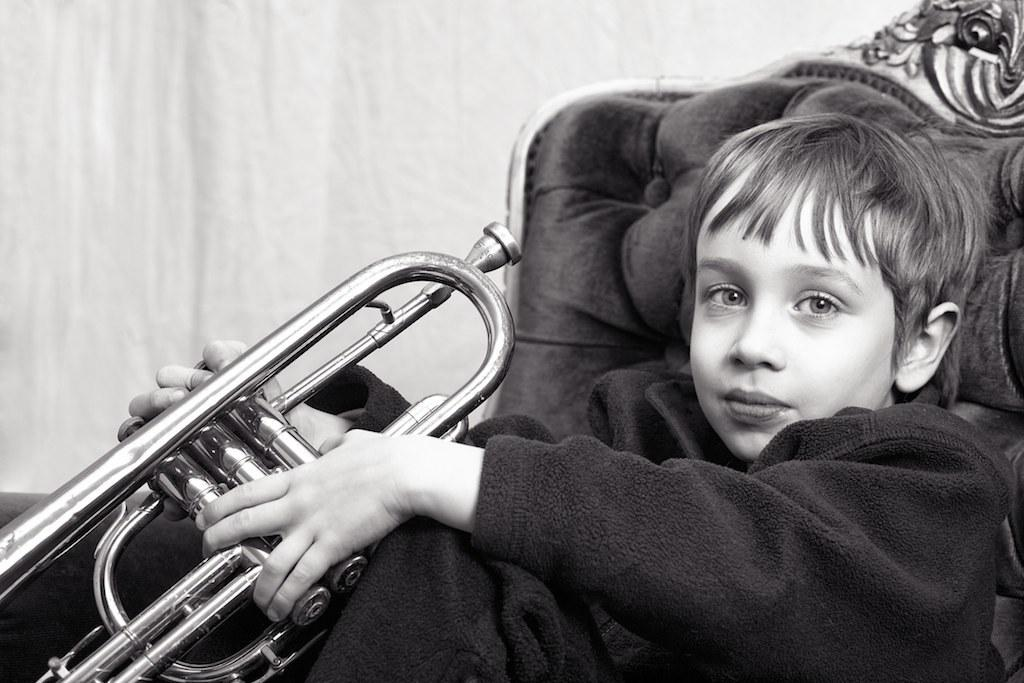What is the color scheme of the image? The image is black and white. What can be seen in the image? There is a person in the image. What is the person doing in the image? The person is holding a musical instrument. Where is the person sitting in the image? The person is sitting on a sofa. What is visible in the background of the image? There is a wall in the background of the image. What type of cloth is being used to cause the person to run in the image? There is no cloth or running depicted in the image; it features a person sitting on a sofa while holding a musical instrument. 